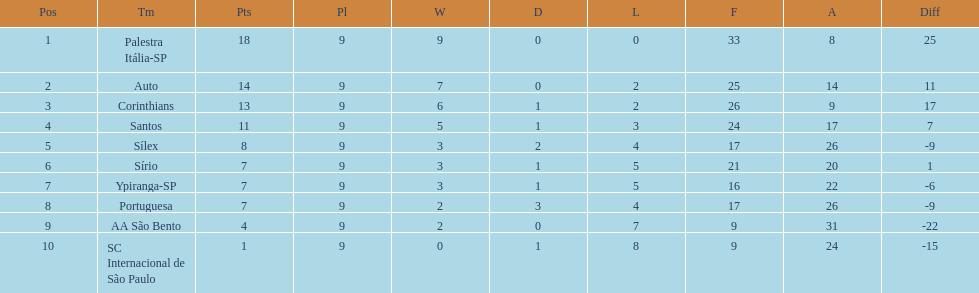How many teams had more points than silex? 4. 